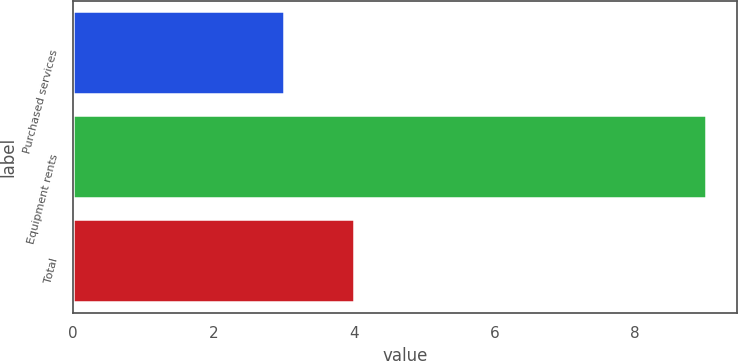<chart> <loc_0><loc_0><loc_500><loc_500><bar_chart><fcel>Purchased services<fcel>Equipment rents<fcel>Total<nl><fcel>3<fcel>9<fcel>4<nl></chart> 